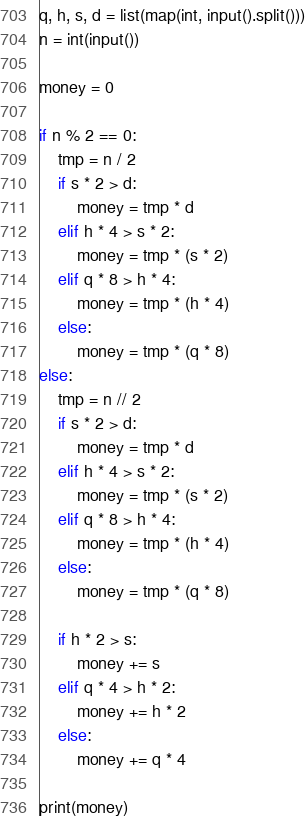Convert code to text. <code><loc_0><loc_0><loc_500><loc_500><_Python_>q, h, s, d = list(map(int, input().split()))
n = int(input())

money = 0

if n % 2 == 0:
    tmp = n / 2
    if s * 2 > d:
        money = tmp * d
    elif h * 4 > s * 2:
        money = tmp * (s * 2)
    elif q * 8 > h * 4:
        money = tmp * (h * 4)
    else:
        money = tmp * (q * 8)
else:
    tmp = n // 2
    if s * 2 > d:
        money = tmp * d
    elif h * 4 > s * 2:
        money = tmp * (s * 2)
    elif q * 8 > h * 4:
        money = tmp * (h * 4)
    else:
        money = tmp * (q * 8)
    
    if h * 2 > s:
        money += s
    elif q * 4 > h * 2:
        money += h * 2
    else:
        money += q * 4

print(money)
</code> 